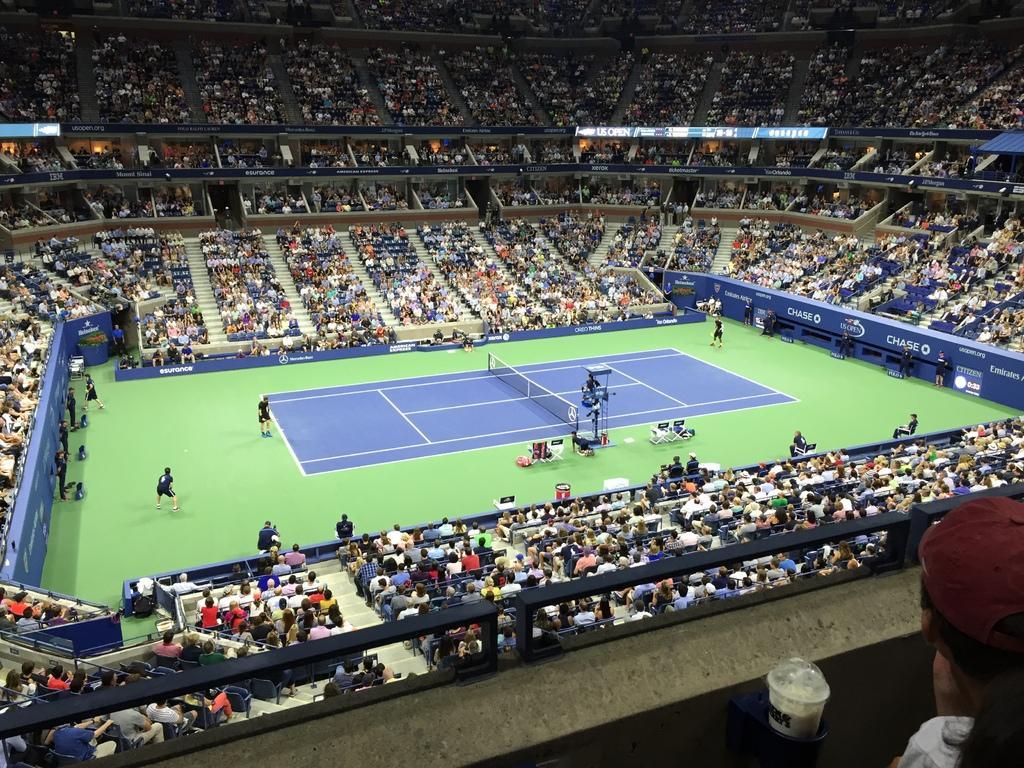Please provide a concise description of this image. In this picture there is a small tennis stadium with players, playing in the courtyard. Around there are many audience in the stadium, sitting and enjoying the game. 